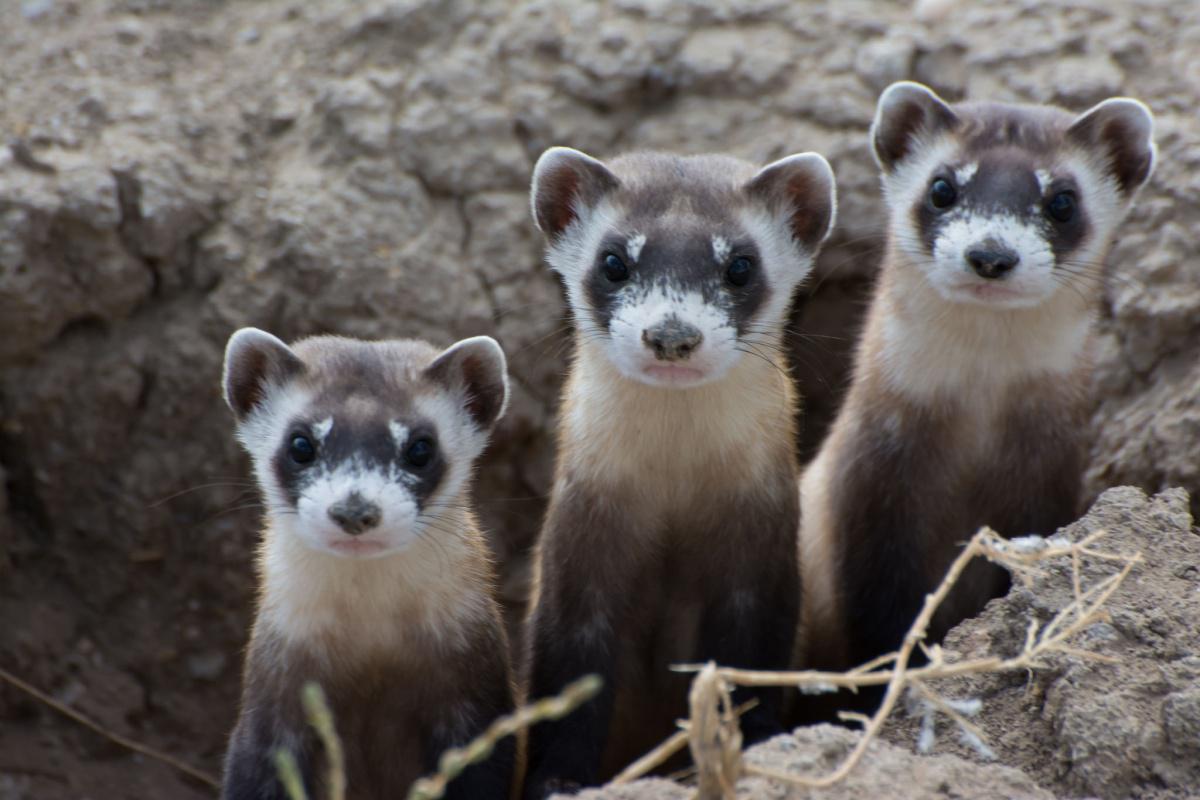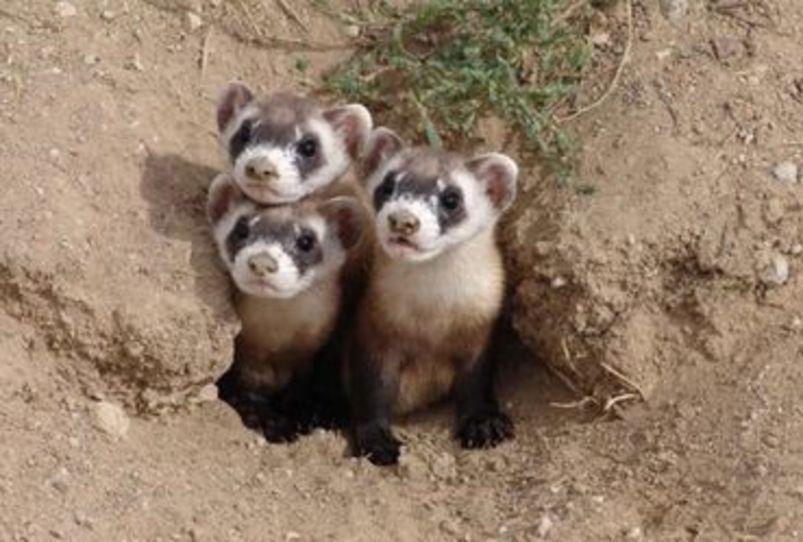The first image is the image on the left, the second image is the image on the right. Assess this claim about the two images: "At least one image has a single animal standing alone.". Correct or not? Answer yes or no. No. The first image is the image on the left, the second image is the image on the right. Analyze the images presented: Is the assertion "There are multiple fuzzy animals facing the same direction in each image." valid? Answer yes or no. Yes. 